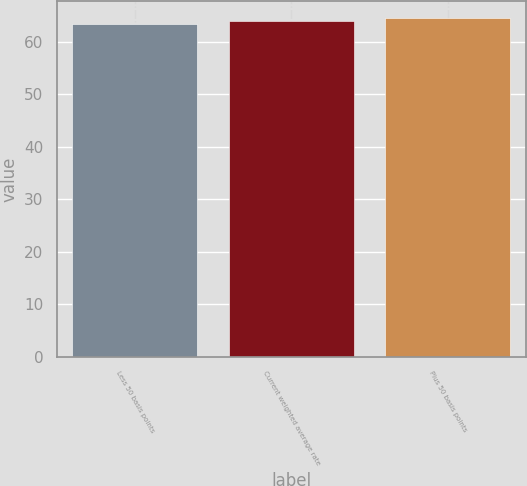Convert chart to OTSL. <chart><loc_0><loc_0><loc_500><loc_500><bar_chart><fcel>Less 50 basis points<fcel>Current weighted average rate<fcel>Plus 50 basis points<nl><fcel>63.5<fcel>63.9<fcel>64.5<nl></chart> 